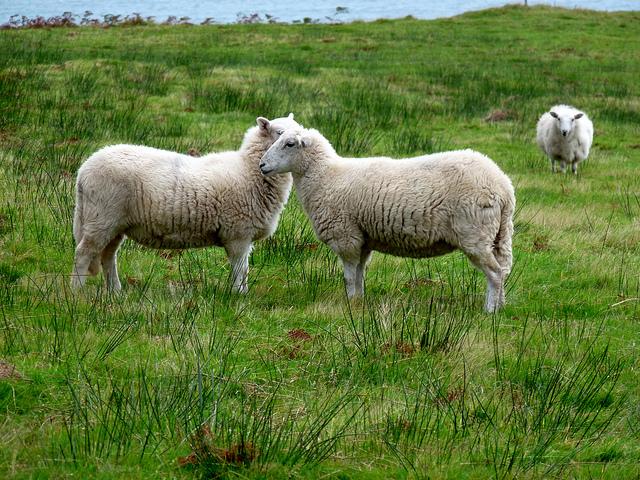Do these animals have horns?
Keep it brief. No. What color is the small sheep's face?
Answer briefly. White. Are the animals fighting?
Answer briefly. No. Does all the sheep have white heads?
Be succinct. Yes. How many lambs?
Keep it brief. 3. Are these animals the same age?
Quick response, please. Yes. Have these sheep been sheared recently?
Concise answer only. No. What type of animal is in the background?
Give a very brief answer. Sheep. What are these two sheep doing?
Quick response, please. Standing. How many sheep are there?
Answer briefly. 3. How many sheep are in the picture?
Quick response, please. 3. Are both animals full grown?
Be succinct. Yes. 